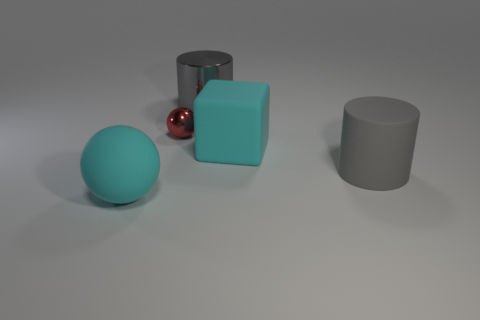Imagine these objects are part of a product design, what could they represent? In a product design context, these objects could represent a modular set with different functions. The cube might be a container or a stand, the cylinder could act as a holder or storage unit, and the red sphere could be a knob or a decorative element. The simplicity suggests a minimalist, perhaps Scandinavian design aesthetic. 